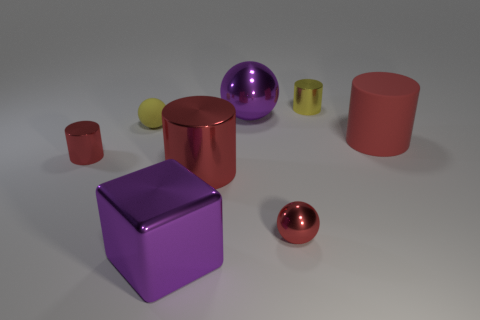Add 2 small red rubber things. How many objects exist? 10 Subtract all big rubber cylinders. How many cylinders are left? 3 Subtract all blocks. How many objects are left? 7 Subtract all cyan balls. How many yellow cylinders are left? 1 Subtract all yellow cylinders. Subtract all tiny red metal cylinders. How many objects are left? 6 Add 8 big purple shiny cubes. How many big purple shiny cubes are left? 9 Add 5 small red objects. How many small red objects exist? 7 Subtract all red cylinders. How many cylinders are left? 1 Subtract 0 blue cubes. How many objects are left? 8 Subtract 1 blocks. How many blocks are left? 0 